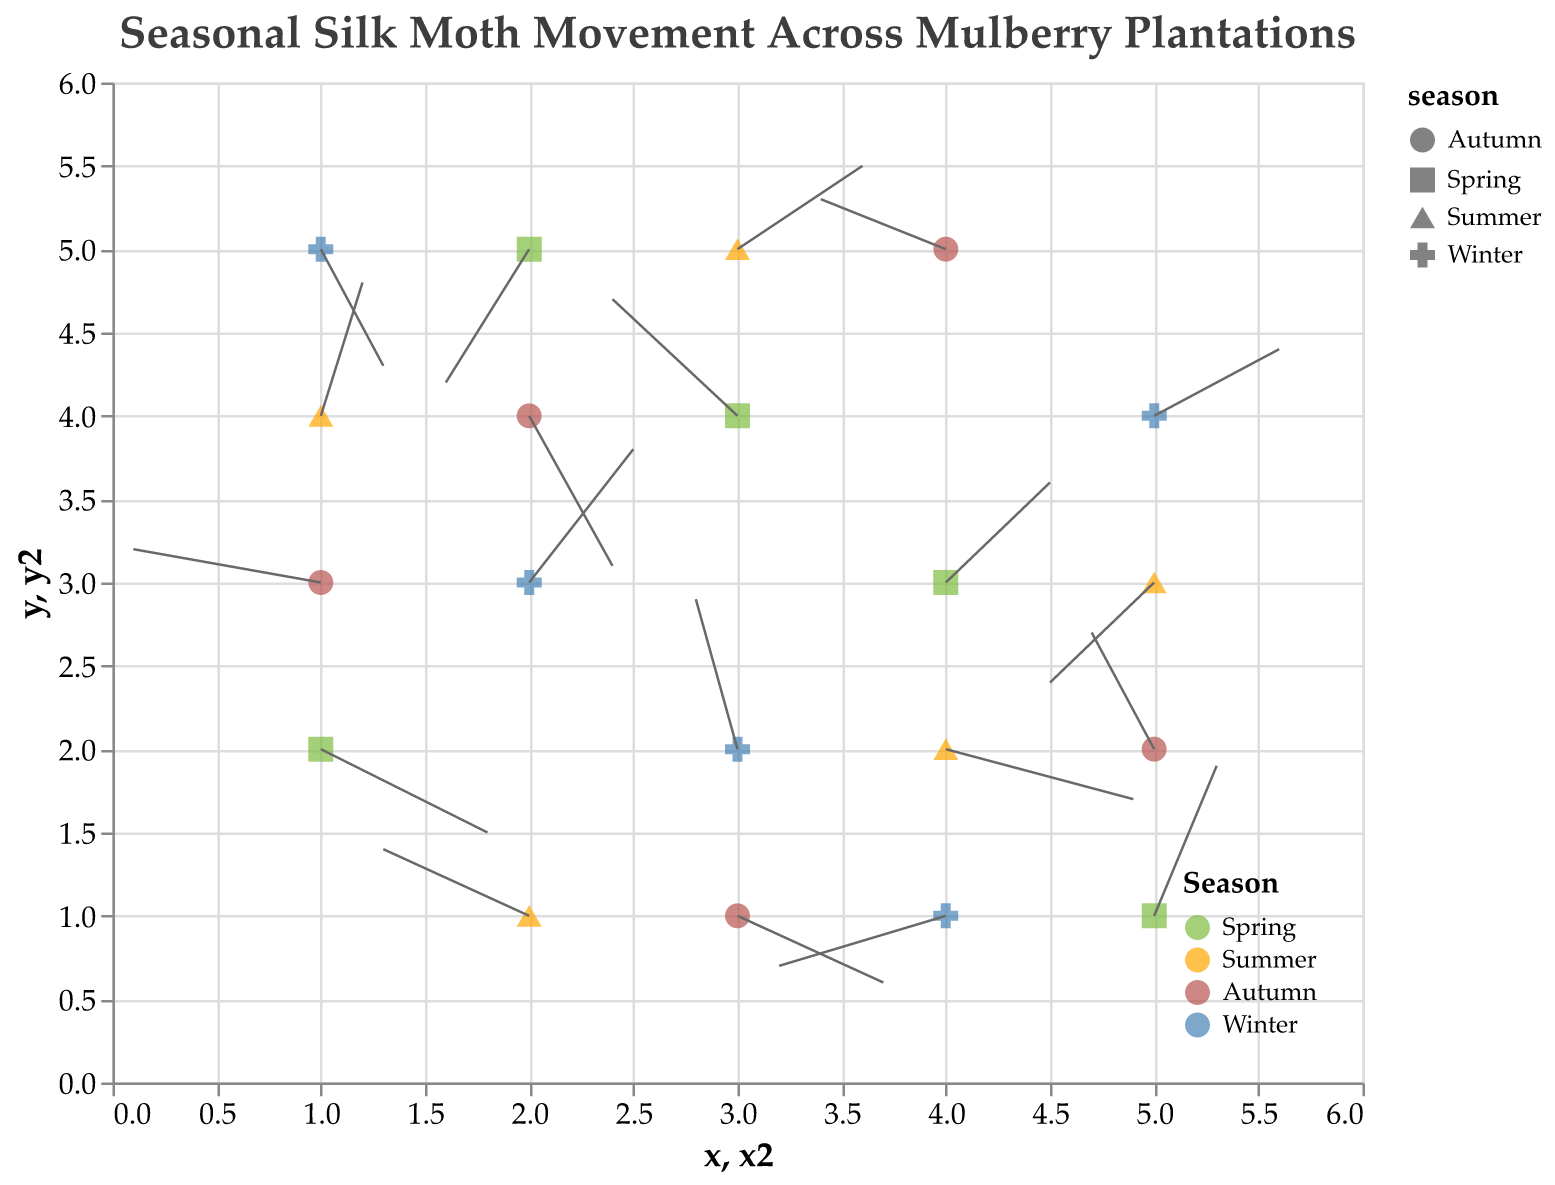What's the title of the figure? The title of the figure is displayed prominently at the top of the chart.
Answer: "Seasonal Silk Moth Movement Across Mulberry Plantations" What are the axis labels on the figure? The x-axis and y-axis labels represent the spatial dimensions of the plantation plot where the silk moth movement is tracked.
Answer: x and y How many data points are plotted in the figure? By counting the individual points on the plot, which are the starting positions for the silk moths for each season, we can determine the number of data points. Each "season" has 5 points, so with 4 seasons: 5 * 4 = 20.
Answer: 20 Which season has the highest number of movement vectors with a positive u-component? By examining the movement vectors for each season and counting those with positive u-components (movement to the right), we identify Spring: vectors (0.8, -0.5), (0.3, 0.9), (0.5, 0.6),  and  Summer: vectors (0.9, -0.3), (0.2, 0.8), (0.6, 0.5),  Autumn: vectors (0.7, -0.4), and Winter: vectors (0.5, 0.8), (0.3, -0.7), (0.6, 0.4). Both Spring and Winter seasons have the same highest count of positive u-components.
Answer: Spring and Winter Which season shows the most varied movement in both u and v components? Examine the vectors for each season and calculate the spread (variance) for u and v components to determine the most varied movement. Spring vectors: (0.8, -0.5), (-0.6, 0.7), (0.3, 0.9), (-0.4, -0.8), (0.5, 0.6)), Summer vectors: (-0.7, 0.4), (0.9, -0.3), (0.2, 0.8), (-0.5, -0.6), (0.6, 0.5), Autumn vectors: (0.7, -0.4), (-0.3, 0.7), (0.4, -0.9), (-0.6, 0.3), Winter vectors: (0.5, 0.8), (-0.8, -0.3), (0.3, -0.7), (0.6, 0.4), (-0.2, 0.9). The varied movement is maximum in Spring and Summer.
Answer: Spring and Summer Are there any vectors in Winter season with both positive u and v components? Looking at the vectors for Winter, these are (0.5, 0.8), (-0.8, -0.3), (0.3, -0.7), (0.6, 0.4), (-0.2, 0.9). Vectors (0.5, 0.8) and (0.6, 0.4) have both u and v components positive.
Answer: Yes Is there any season where the vector movement seems to cluster in a particular region? By observing the plot locations and directions, the clustering effect can be checked. We see that vectors in Spring: (5,1), (2,5), (1,2), (4,3), (3,4) shows that vectors are spread out well except (4,3) and (3,4) around mid-region as clusters are more evident in Winter and Summer regions.
Answer: No, other than slight clustering in mid of Spring Are the vectors in Autumn more horizontally or vertically inclined? Inspecting the vectors for Autumn season ((-0.9, 0.2), (0.7, -0.4), (-0.3, 0.7), (0.4, -0.9), (-0.6, 0.3)), and comparing the magnitudes of u and v values will indicate if they have a larger e.g., horizontal inclination -> larger u, vertical inclination -> larger v. There are a mix of positive negative both of u and v.
Answer: Both Horizontally and Vertically inclined 